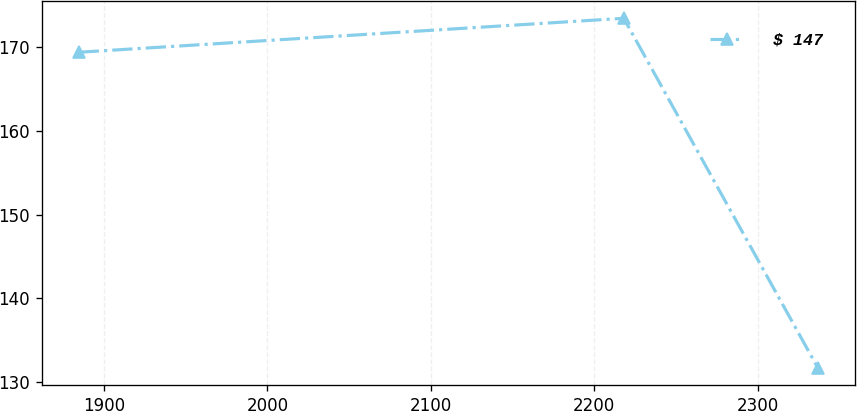Convert chart to OTSL. <chart><loc_0><loc_0><loc_500><loc_500><line_chart><ecel><fcel>$ 147<nl><fcel>1884.55<fcel>169.41<nl><fcel>2218.05<fcel>173.47<nl><fcel>2336.84<fcel>131.68<nl></chart> 